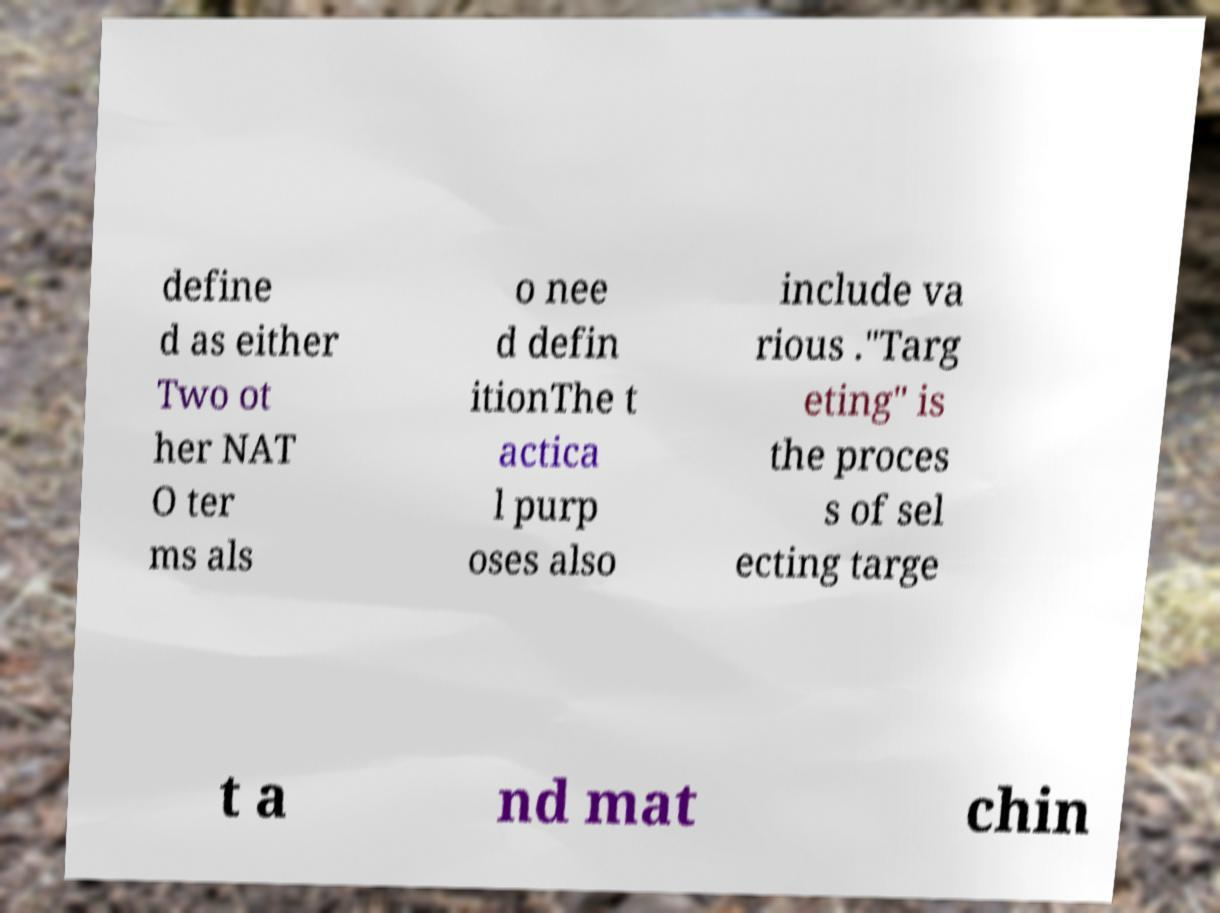I need the written content from this picture converted into text. Can you do that? define d as either Two ot her NAT O ter ms als o nee d defin itionThe t actica l purp oses also include va rious ."Targ eting" is the proces s of sel ecting targe t a nd mat chin 